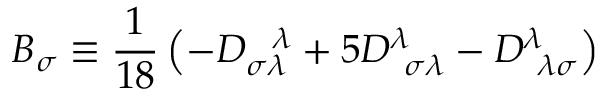Convert formula to latex. <formula><loc_0><loc_0><loc_500><loc_500>B _ { \sigma } \equiv \frac { 1 } { 1 8 } \left ( - D _ { \sigma \lambda } ^ { \lambda } + 5 D _ { \sigma \lambda } ^ { \lambda } - D _ { \lambda \sigma } ^ { \lambda } \right )</formula> 